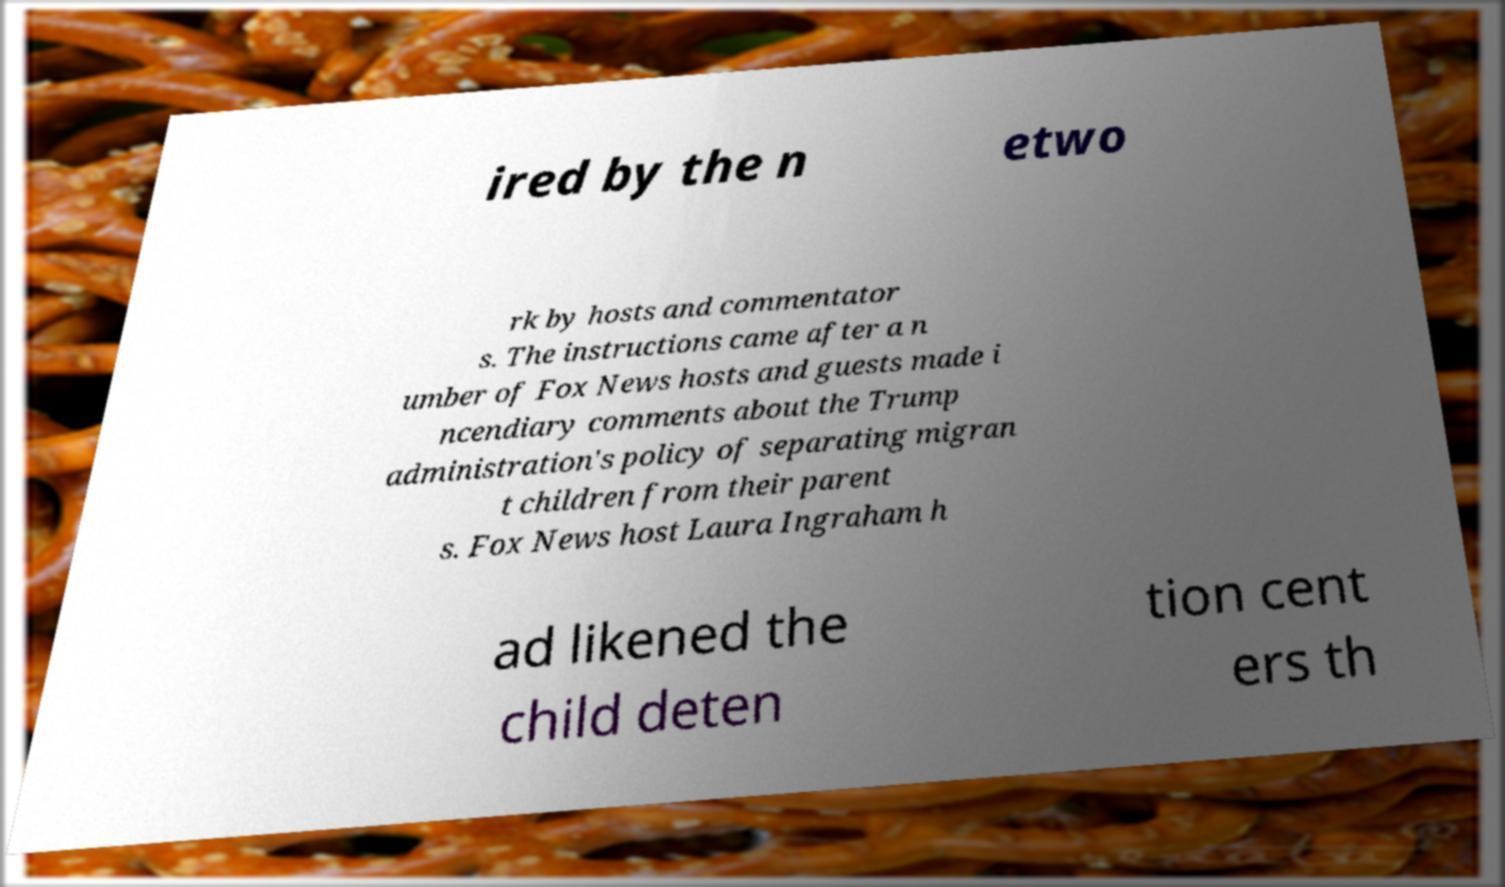For documentation purposes, I need the text within this image transcribed. Could you provide that? ired by the n etwo rk by hosts and commentator s. The instructions came after a n umber of Fox News hosts and guests made i ncendiary comments about the Trump administration's policy of separating migran t children from their parent s. Fox News host Laura Ingraham h ad likened the child deten tion cent ers th 